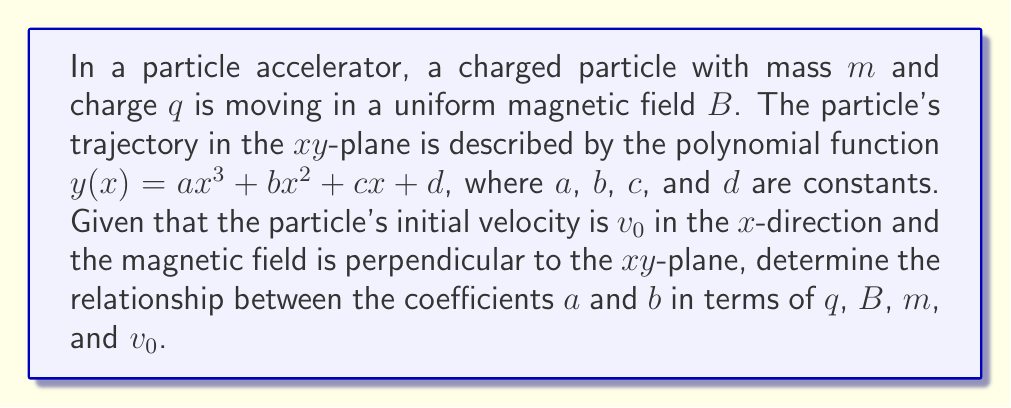Can you answer this question? 1) The Lorentz force equation for a particle in a magnetic field is:
   $$\vec{F} = q(\vec{v} \times \vec{B})$$

2) In the $xy$-plane with $\vec{B}$ perpendicular, this becomes:
   $$F_y = qv_xB$$

3) From Newton's Second Law:
   $$F_y = ma_y = m\frac{d^2y}{dt^2}$$

4) Equating these:
   $$m\frac{d^2y}{dt^2} = qv_xB$$

5) We need to express $\frac{d^2y}{dt^2}$ in terms of $x$. Using the chain rule:
   $$\frac{d^2y}{dt^2} = \frac{d^2y}{dx^2}\left(\frac{dx}{dt}\right)^2 + \frac{dy}{dx}\frac{d^2x}{dt^2}$$

6) The acceleration in the $x$-direction is zero, so $\frac{d^2x}{dt^2} = 0$. Also, $\frac{dx}{dt} = v_x \approx v_0$ for small deflections. Thus:
   $$\frac{d^2y}{dt^2} = v_0^2\frac{d^2y}{dx^2}$$

7) Substituting this back into the equation from step 4:
   $$mv_0^2\frac{d^2y}{dx^2} = qv_0B$$

8) Simplifying:
   $$\frac{d^2y}{dx^2} = \frac{qB}{mv_0}$$

9) Now, let's consider our polynomial $y(x) = ax^3 + bx^2 + cx + d$. Its second derivative is:
   $$\frac{d^2y}{dx^2} = 6ax + 2b$$

10) Equating this with the result from step 8:
    $$6ax + 2b = \frac{qB}{mv_0}$$

11) For this to be true for all $x$, we must have:
    $$6a = 0 \quad \text{and} \quad 2b = \frac{qB}{mv_0}$$

12) From the first equation, $a = 0$. From the second:
    $$b = \frac{qB}{2mv_0}$$

Therefore, the relationship between $a$ and $b$ is:
$$a = 0 \quad \text{and} \quad b = \frac{qB}{2mv_0}$$
Answer: $a = 0$, $b = \frac{qB}{2mv_0}$ 